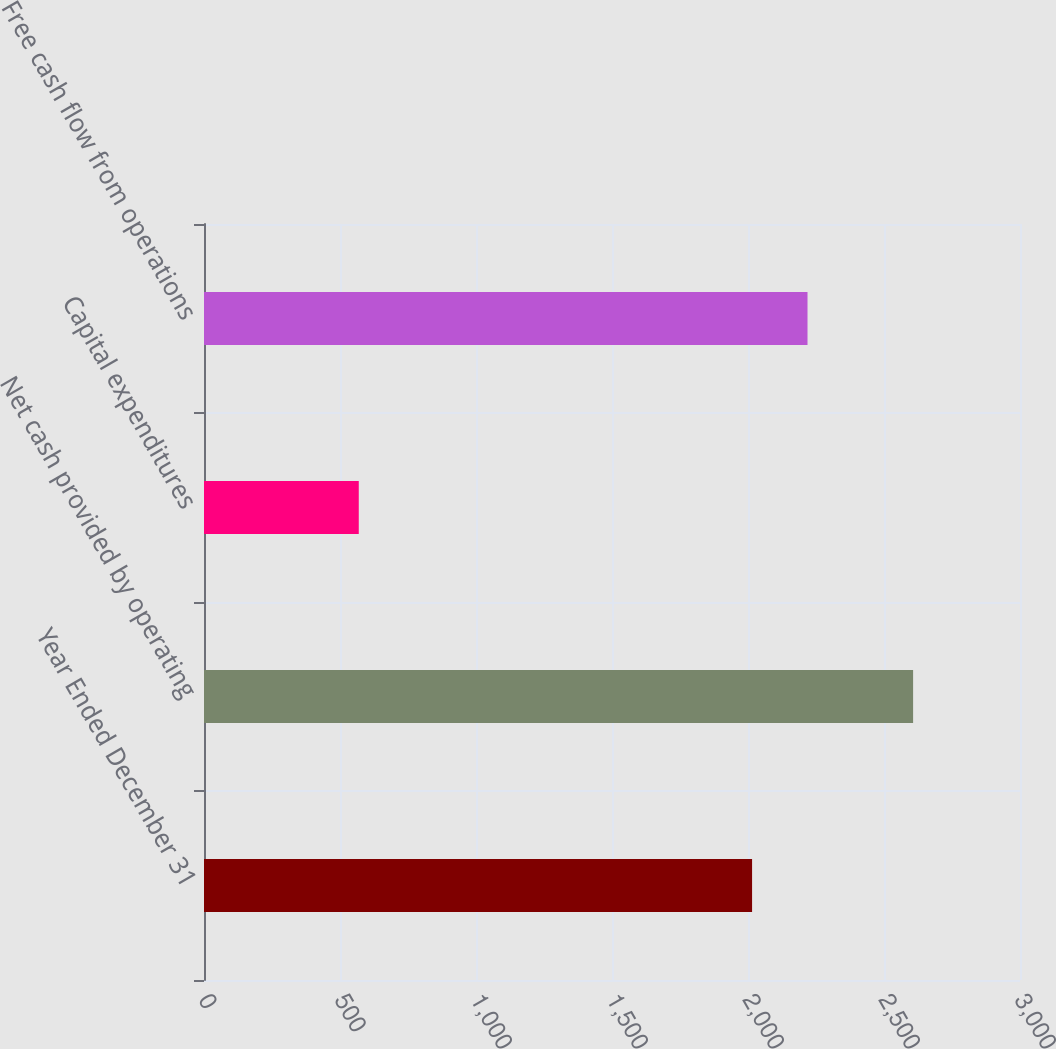Convert chart. <chart><loc_0><loc_0><loc_500><loc_500><bar_chart><fcel>Year Ended December 31<fcel>Net cash provided by operating<fcel>Capital expenditures<fcel>Free cash flow from operations<nl><fcel>2015<fcel>2607<fcel>569<fcel>2218.8<nl></chart> 